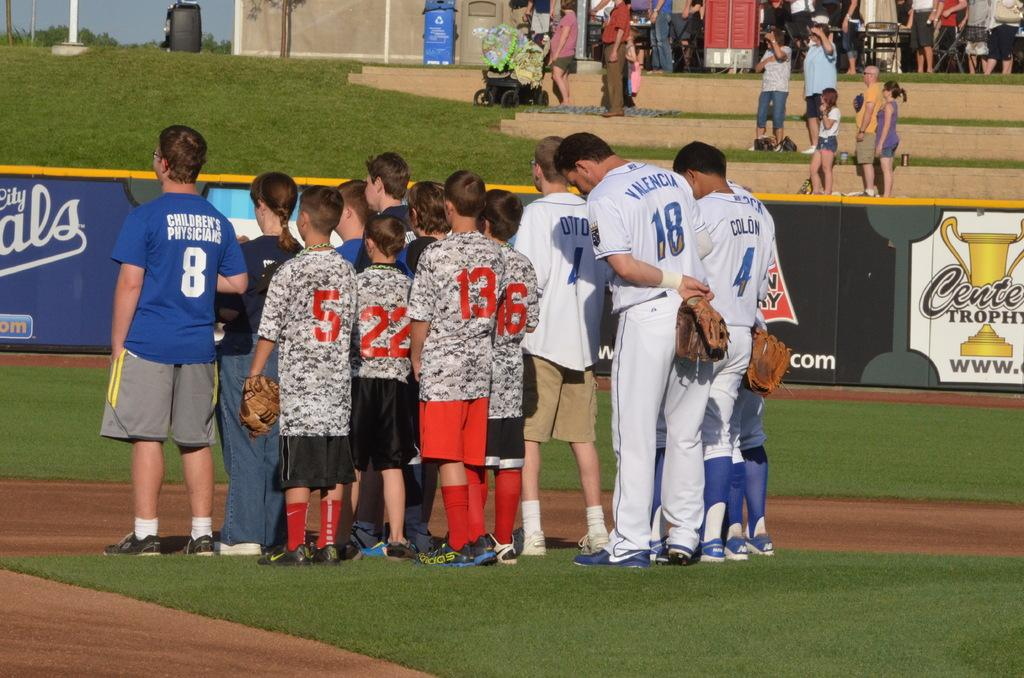<image>
Summarize the visual content of the image. The people are on the baseball field, the numbers on the shirts include 8, 5, 22, 13, 16, 18 and 4. 